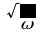<formula> <loc_0><loc_0><loc_500><loc_500>\sqrt { \omega }</formula> 